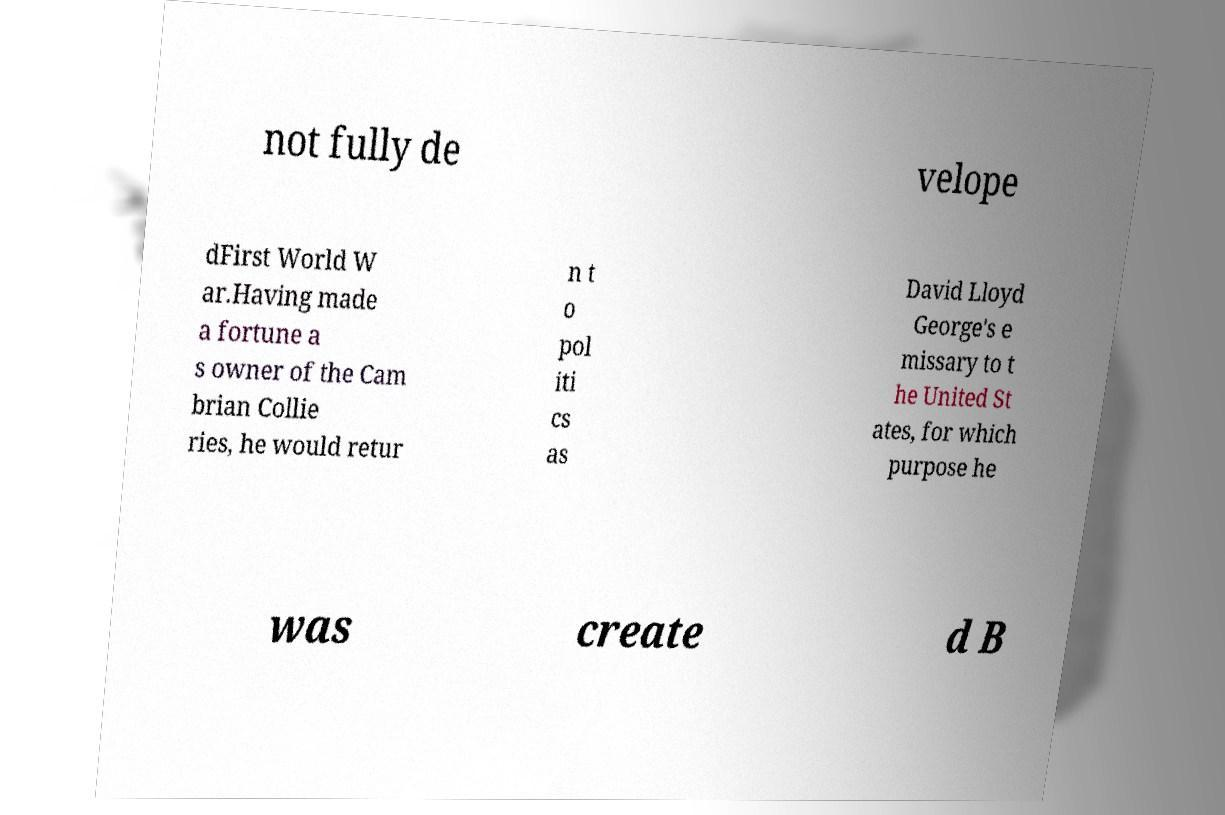I need the written content from this picture converted into text. Can you do that? not fully de velope dFirst World W ar.Having made a fortune a s owner of the Cam brian Collie ries, he would retur n t o pol iti cs as David Lloyd George's e missary to t he United St ates, for which purpose he was create d B 